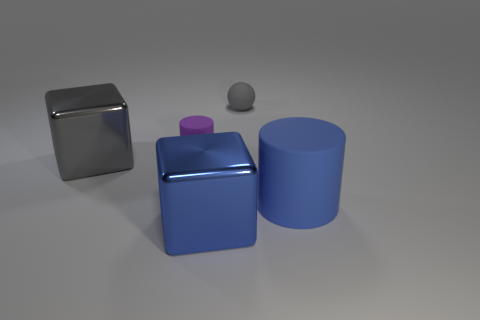What is the material of the large gray object that is the same shape as the big blue shiny thing?
Your answer should be compact. Metal. How many gray shiny objects have the same shape as the blue shiny object?
Ensure brevity in your answer.  1. Is the number of blue matte objects behind the small gray matte thing less than the number of gray matte spheres behind the gray cube?
Your answer should be compact. Yes. There is a big blue metal block that is in front of the blue rubber cylinder; how many large blocks are right of it?
Provide a succinct answer. 0. Is there a large yellow matte cylinder?
Keep it short and to the point. No. Are there any purple cylinders made of the same material as the small gray sphere?
Offer a very short reply. Yes. Are there more big gray shiny things behind the rubber ball than large metal things that are behind the big gray shiny object?
Offer a very short reply. No. Do the blue metal cube and the matte ball have the same size?
Your answer should be compact. No. What is the color of the matte cylinder that is behind the metallic thing left of the purple matte thing?
Keep it short and to the point. Purple. The tiny matte cylinder has what color?
Your answer should be compact. Purple. 